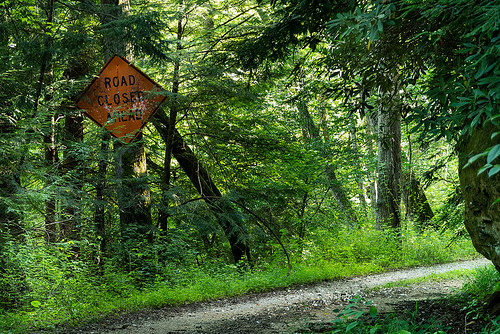<image>
Is the road sign on the tree? Yes. Looking at the image, I can see the road sign is positioned on top of the tree, with the tree providing support. Is there a sign in front of the tree? Yes. The sign is positioned in front of the tree, appearing closer to the camera viewpoint. 